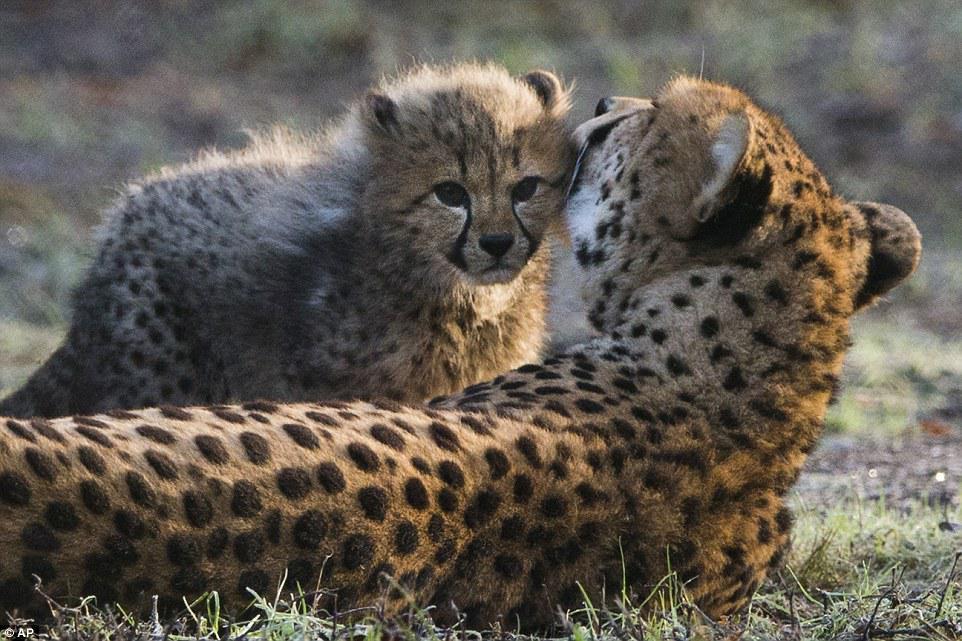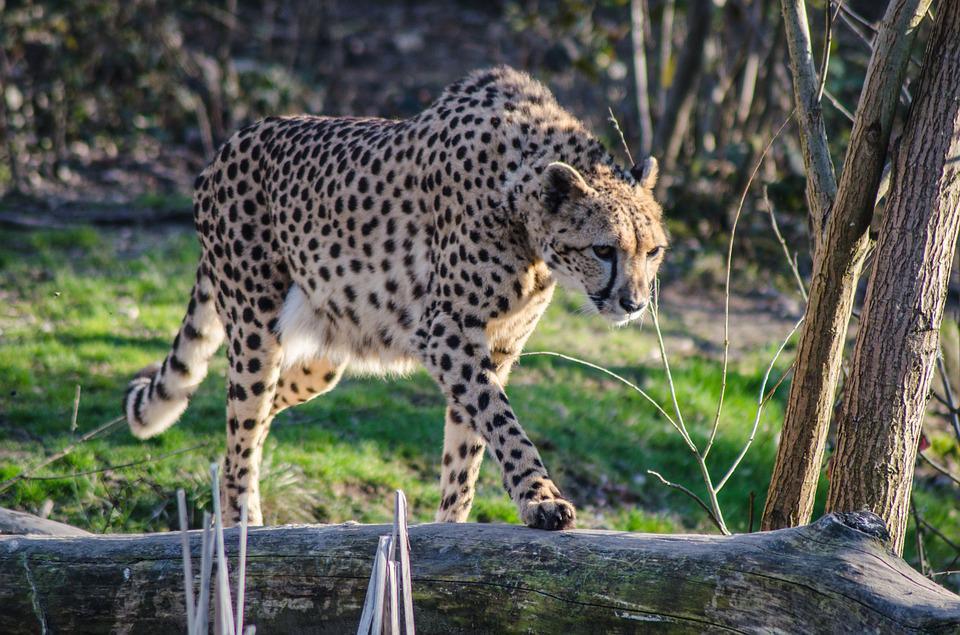The first image is the image on the left, the second image is the image on the right. Given the left and right images, does the statement "Three cats are lying down, with more in the image on the right." hold true? Answer yes or no. No. The first image is the image on the left, the second image is the image on the right. Considering the images on both sides, is "The left image contains one cheetah, an adult lying on the ground, and the other image features a reclining adult cheetah with its head facing forward on the right, and a cheetah kitten in front of it with its head turned forward on the left." valid? Answer yes or no. No. 